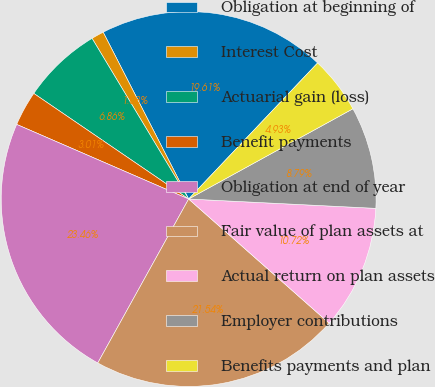<chart> <loc_0><loc_0><loc_500><loc_500><pie_chart><fcel>Obligation at beginning of<fcel>Interest Cost<fcel>Actuarial gain (loss)<fcel>Benefit payments<fcel>Obligation at end of year<fcel>Fair value of plan assets at<fcel>Actual return on plan assets<fcel>Employer contributions<fcel>Benefits payments and plan<nl><fcel>19.61%<fcel>1.08%<fcel>6.86%<fcel>3.01%<fcel>23.46%<fcel>21.54%<fcel>10.72%<fcel>8.79%<fcel>4.93%<nl></chart> 